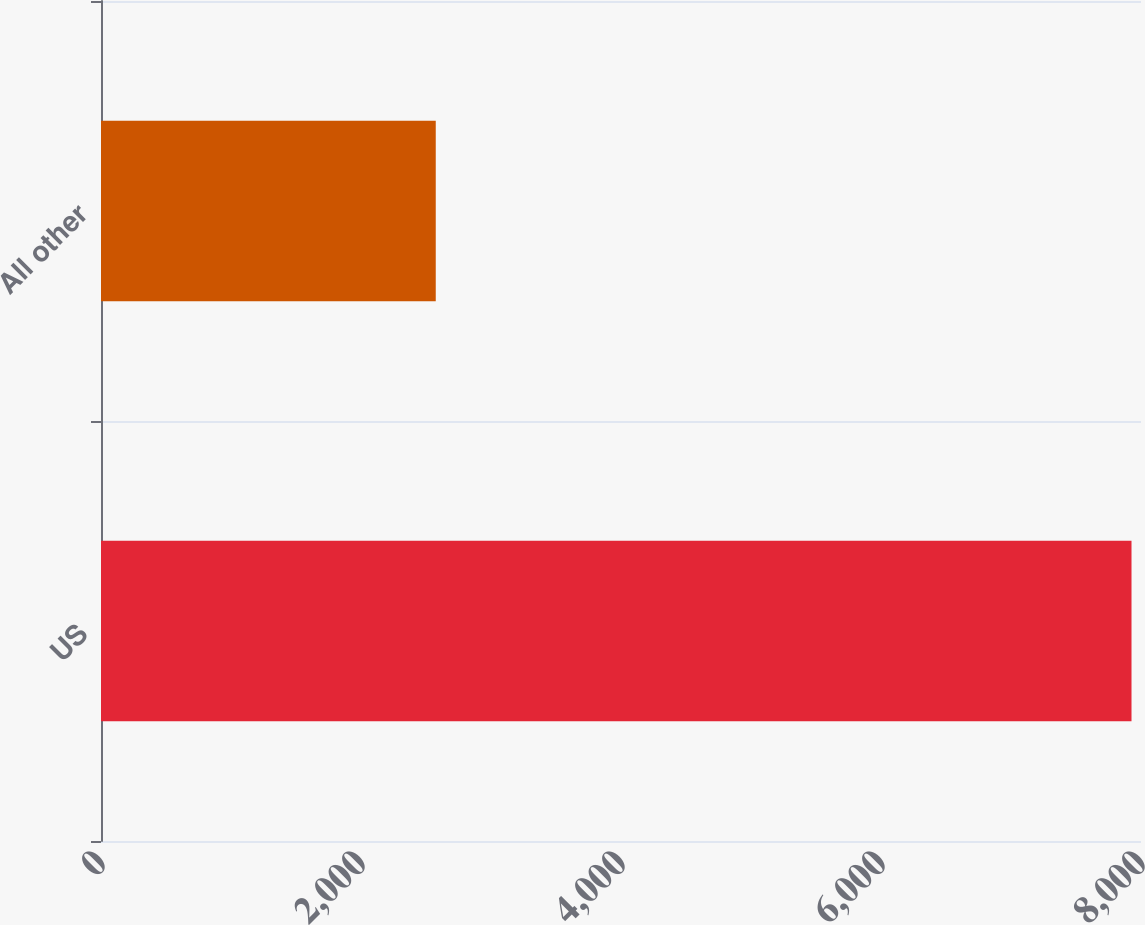<chart> <loc_0><loc_0><loc_500><loc_500><bar_chart><fcel>US<fcel>All other<nl><fcel>7927<fcel>2575<nl></chart> 